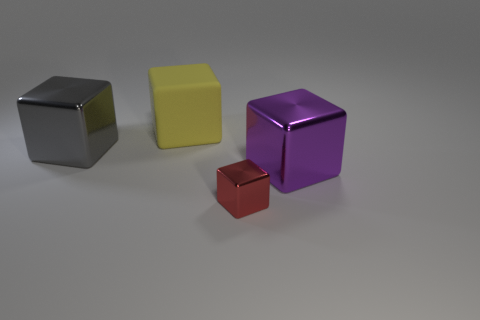There is a object in front of the purple block; is there a yellow block that is in front of it?
Offer a very short reply. No. There is a yellow matte block; is its size the same as the object left of the large rubber block?
Your response must be concise. Yes. There is a purple shiny thing in front of the metallic block that is left of the big yellow block; is there a yellow matte object behind it?
Ensure brevity in your answer.  Yes. What is the material of the object that is in front of the large purple shiny object?
Your answer should be very brief. Metal. Is the size of the yellow block the same as the red thing?
Provide a short and direct response. No. What color is the large block that is right of the gray metallic thing and in front of the large yellow cube?
Your response must be concise. Purple. The gray object that is made of the same material as the tiny red thing is what shape?
Your response must be concise. Cube. How many cubes are both on the right side of the red thing and to the left of the small thing?
Offer a very short reply. 0. There is a big yellow object; are there any big purple blocks behind it?
Provide a succinct answer. No. Do the shiny object that is on the left side of the yellow rubber block and the thing on the right side of the tiny object have the same shape?
Keep it short and to the point. Yes. 